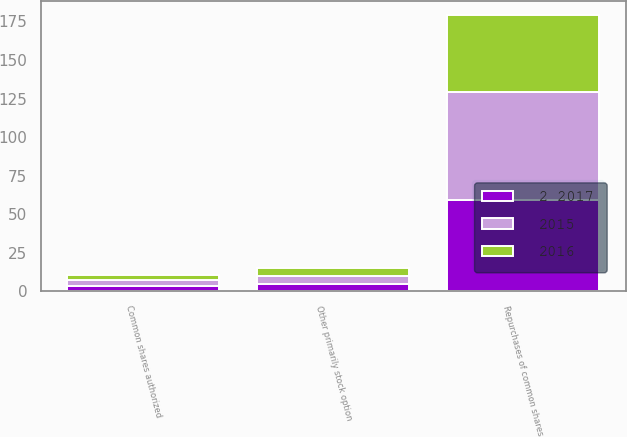Convert chart. <chart><loc_0><loc_0><loc_500><loc_500><stacked_bar_chart><ecel><fcel>Common shares authorized<fcel>Repurchases of common shares<fcel>Other primarily stock option<nl><fcel>2016<fcel>3.6<fcel>50<fcel>5<nl><fcel>2015<fcel>3.6<fcel>70<fcel>5<nl><fcel>2 2017<fcel>3.6<fcel>59<fcel>5<nl></chart> 